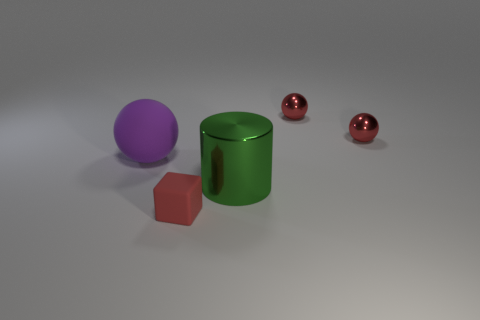Add 1 purple objects. How many objects exist? 6 Subtract all blocks. How many objects are left? 4 Add 3 small yellow balls. How many small yellow balls exist? 3 Subtract 0 purple blocks. How many objects are left? 5 Subtract all tiny gray rubber cylinders. Subtract all red matte objects. How many objects are left? 4 Add 3 purple matte things. How many purple matte things are left? 4 